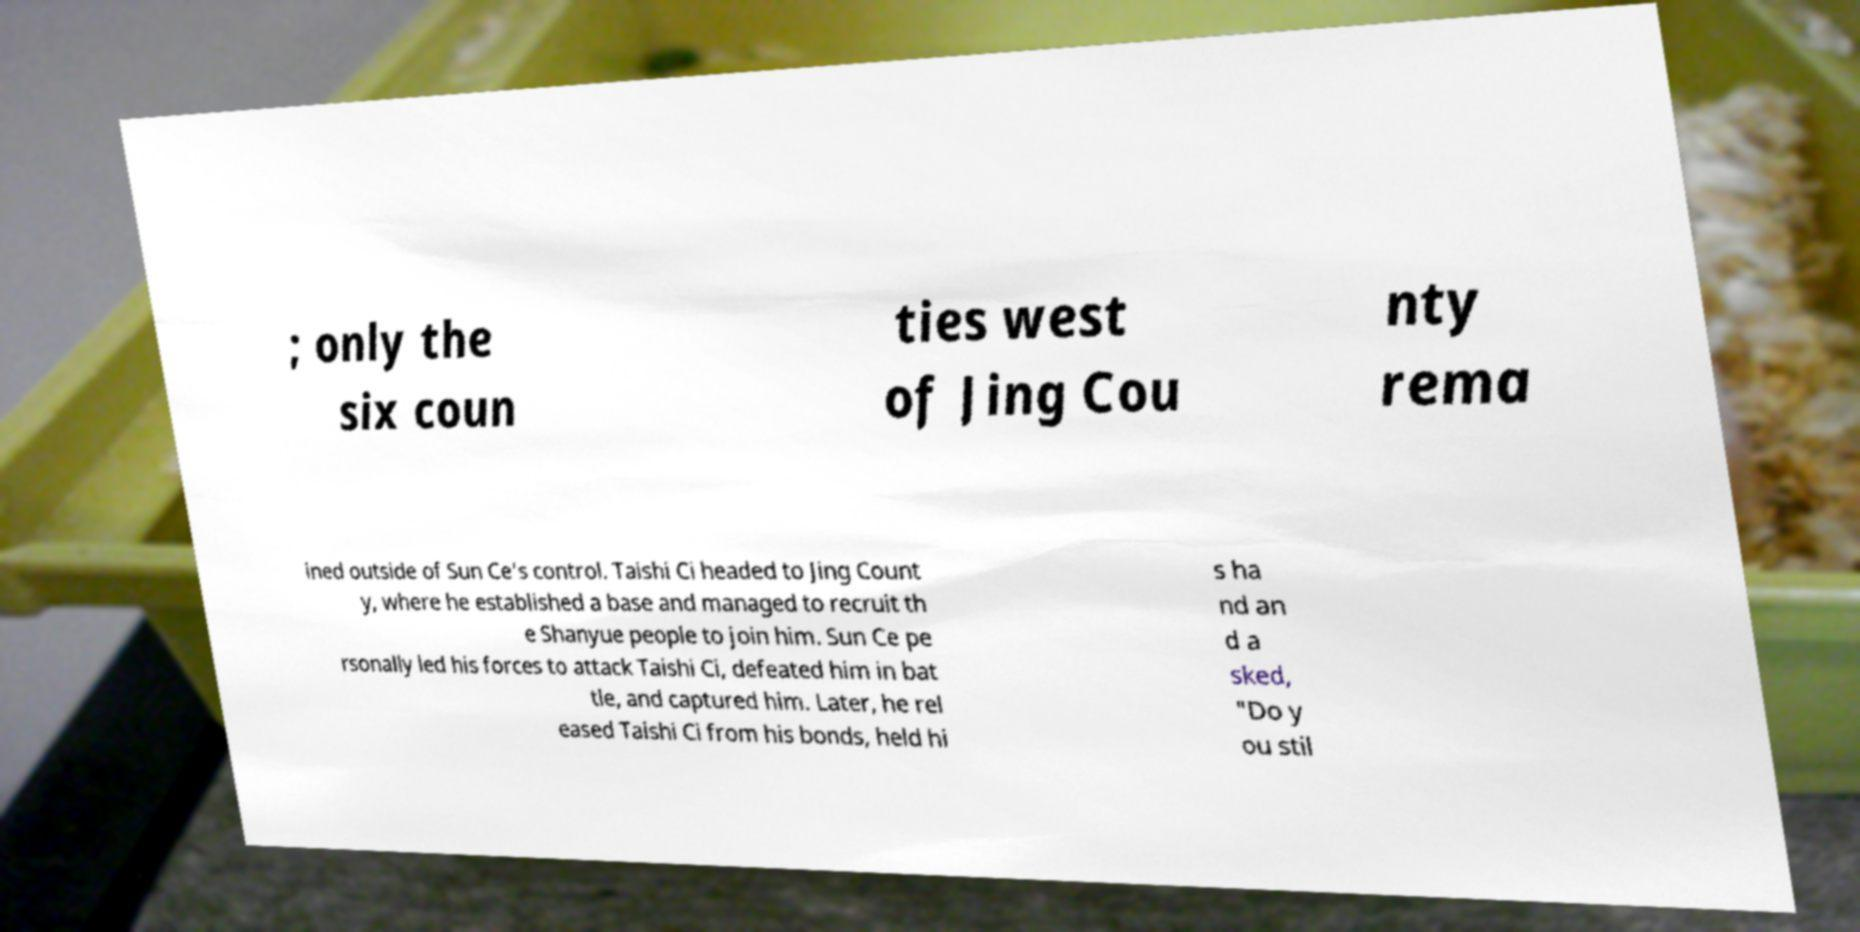Could you extract and type out the text from this image? ; only the six coun ties west of Jing Cou nty rema ined outside of Sun Ce's control. Taishi Ci headed to Jing Count y, where he established a base and managed to recruit th e Shanyue people to join him. Sun Ce pe rsonally led his forces to attack Taishi Ci, defeated him in bat tle, and captured him. Later, he rel eased Taishi Ci from his bonds, held hi s ha nd an d a sked, "Do y ou stil 